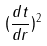Convert formula to latex. <formula><loc_0><loc_0><loc_500><loc_500>( \frac { d t } { d r } ) ^ { 2 }</formula> 